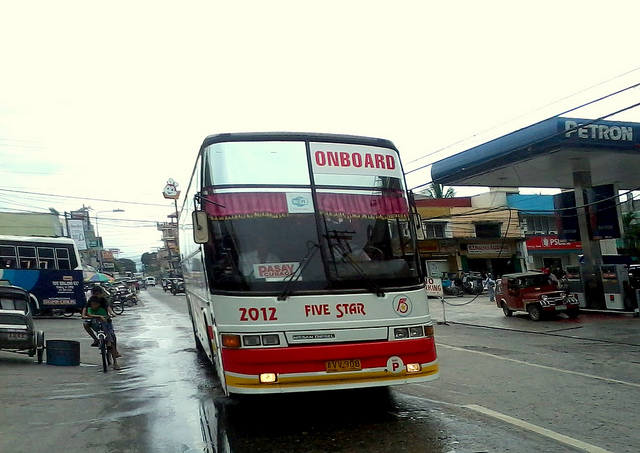Read all the text in this image. ONBOARD PASAY 2012 FIVE STAR P PS PETRON 